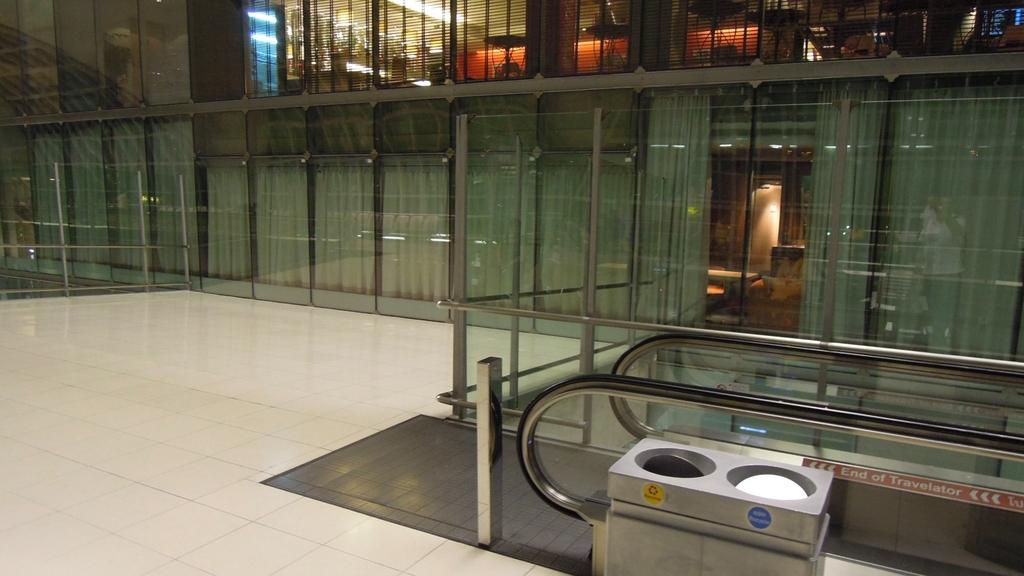What type of transportation is that?
Offer a very short reply. Travelator. 